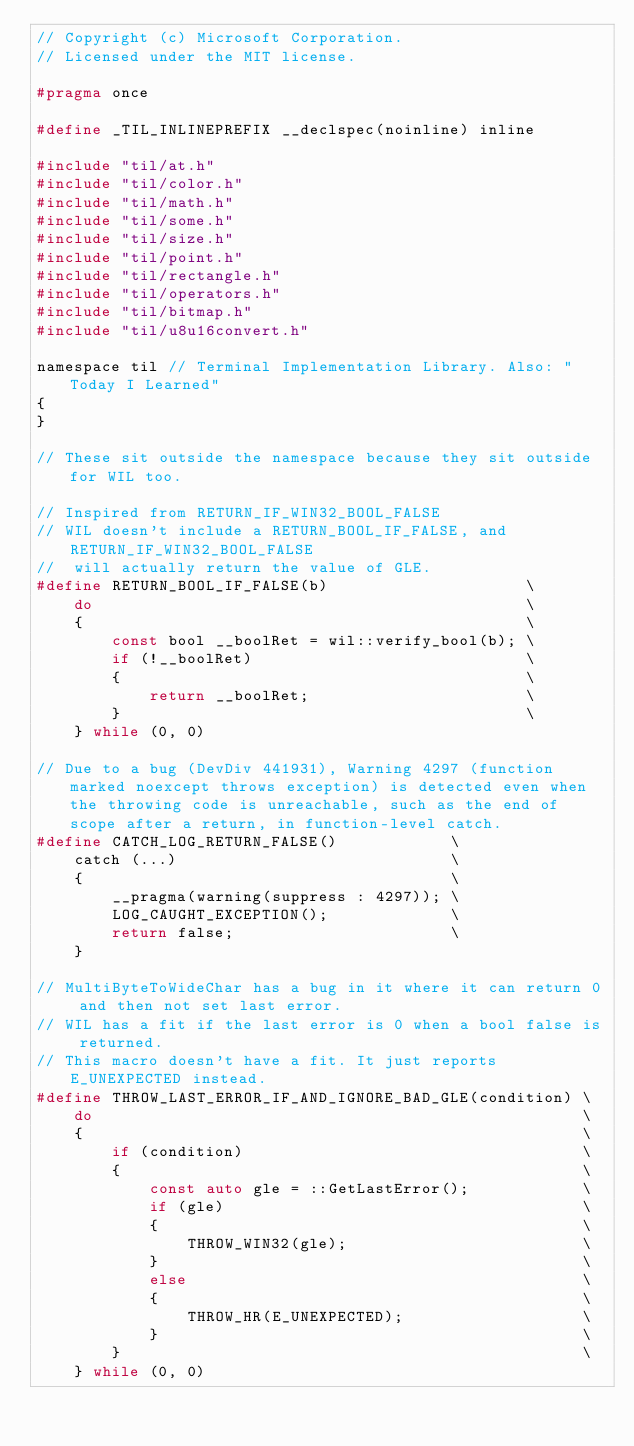Convert code to text. <code><loc_0><loc_0><loc_500><loc_500><_C_>// Copyright (c) Microsoft Corporation.
// Licensed under the MIT license.

#pragma once

#define _TIL_INLINEPREFIX __declspec(noinline) inline

#include "til/at.h"
#include "til/color.h"
#include "til/math.h"
#include "til/some.h"
#include "til/size.h"
#include "til/point.h"
#include "til/rectangle.h"
#include "til/operators.h"
#include "til/bitmap.h"
#include "til/u8u16convert.h"

namespace til // Terminal Implementation Library. Also: "Today I Learned"
{
}

// These sit outside the namespace because they sit outside for WIL too.

// Inspired from RETURN_IF_WIN32_BOOL_FALSE
// WIL doesn't include a RETURN_BOOL_IF_FALSE, and RETURN_IF_WIN32_BOOL_FALSE
//  will actually return the value of GLE.
#define RETURN_BOOL_IF_FALSE(b)                     \
    do                                              \
    {                                               \
        const bool __boolRet = wil::verify_bool(b); \
        if (!__boolRet)                             \
        {                                           \
            return __boolRet;                       \
        }                                           \
    } while (0, 0)

// Due to a bug (DevDiv 441931), Warning 4297 (function marked noexcept throws exception) is detected even when the throwing code is unreachable, such as the end of scope after a return, in function-level catch.
#define CATCH_LOG_RETURN_FALSE()            \
    catch (...)                             \
    {                                       \
        __pragma(warning(suppress : 4297)); \
        LOG_CAUGHT_EXCEPTION();             \
        return false;                       \
    }

// MultiByteToWideChar has a bug in it where it can return 0 and then not set last error.
// WIL has a fit if the last error is 0 when a bool false is returned.
// This macro doesn't have a fit. It just reports E_UNEXPECTED instead.
#define THROW_LAST_ERROR_IF_AND_IGNORE_BAD_GLE(condition) \
    do                                                    \
    {                                                     \
        if (condition)                                    \
        {                                                 \
            const auto gle = ::GetLastError();            \
            if (gle)                                      \
            {                                             \
                THROW_WIN32(gle);                         \
            }                                             \
            else                                          \
            {                                             \
                THROW_HR(E_UNEXPECTED);                   \
            }                                             \
        }                                                 \
    } while (0, 0)
</code> 